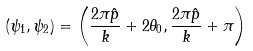<formula> <loc_0><loc_0><loc_500><loc_500>( \psi _ { 1 } , \psi _ { 2 } ) = \left ( \frac { 2 \pi \hat { p } } { k } + 2 \theta _ { 0 } , \frac { 2 \pi \hat { p } } { k } + \pi \right )</formula> 